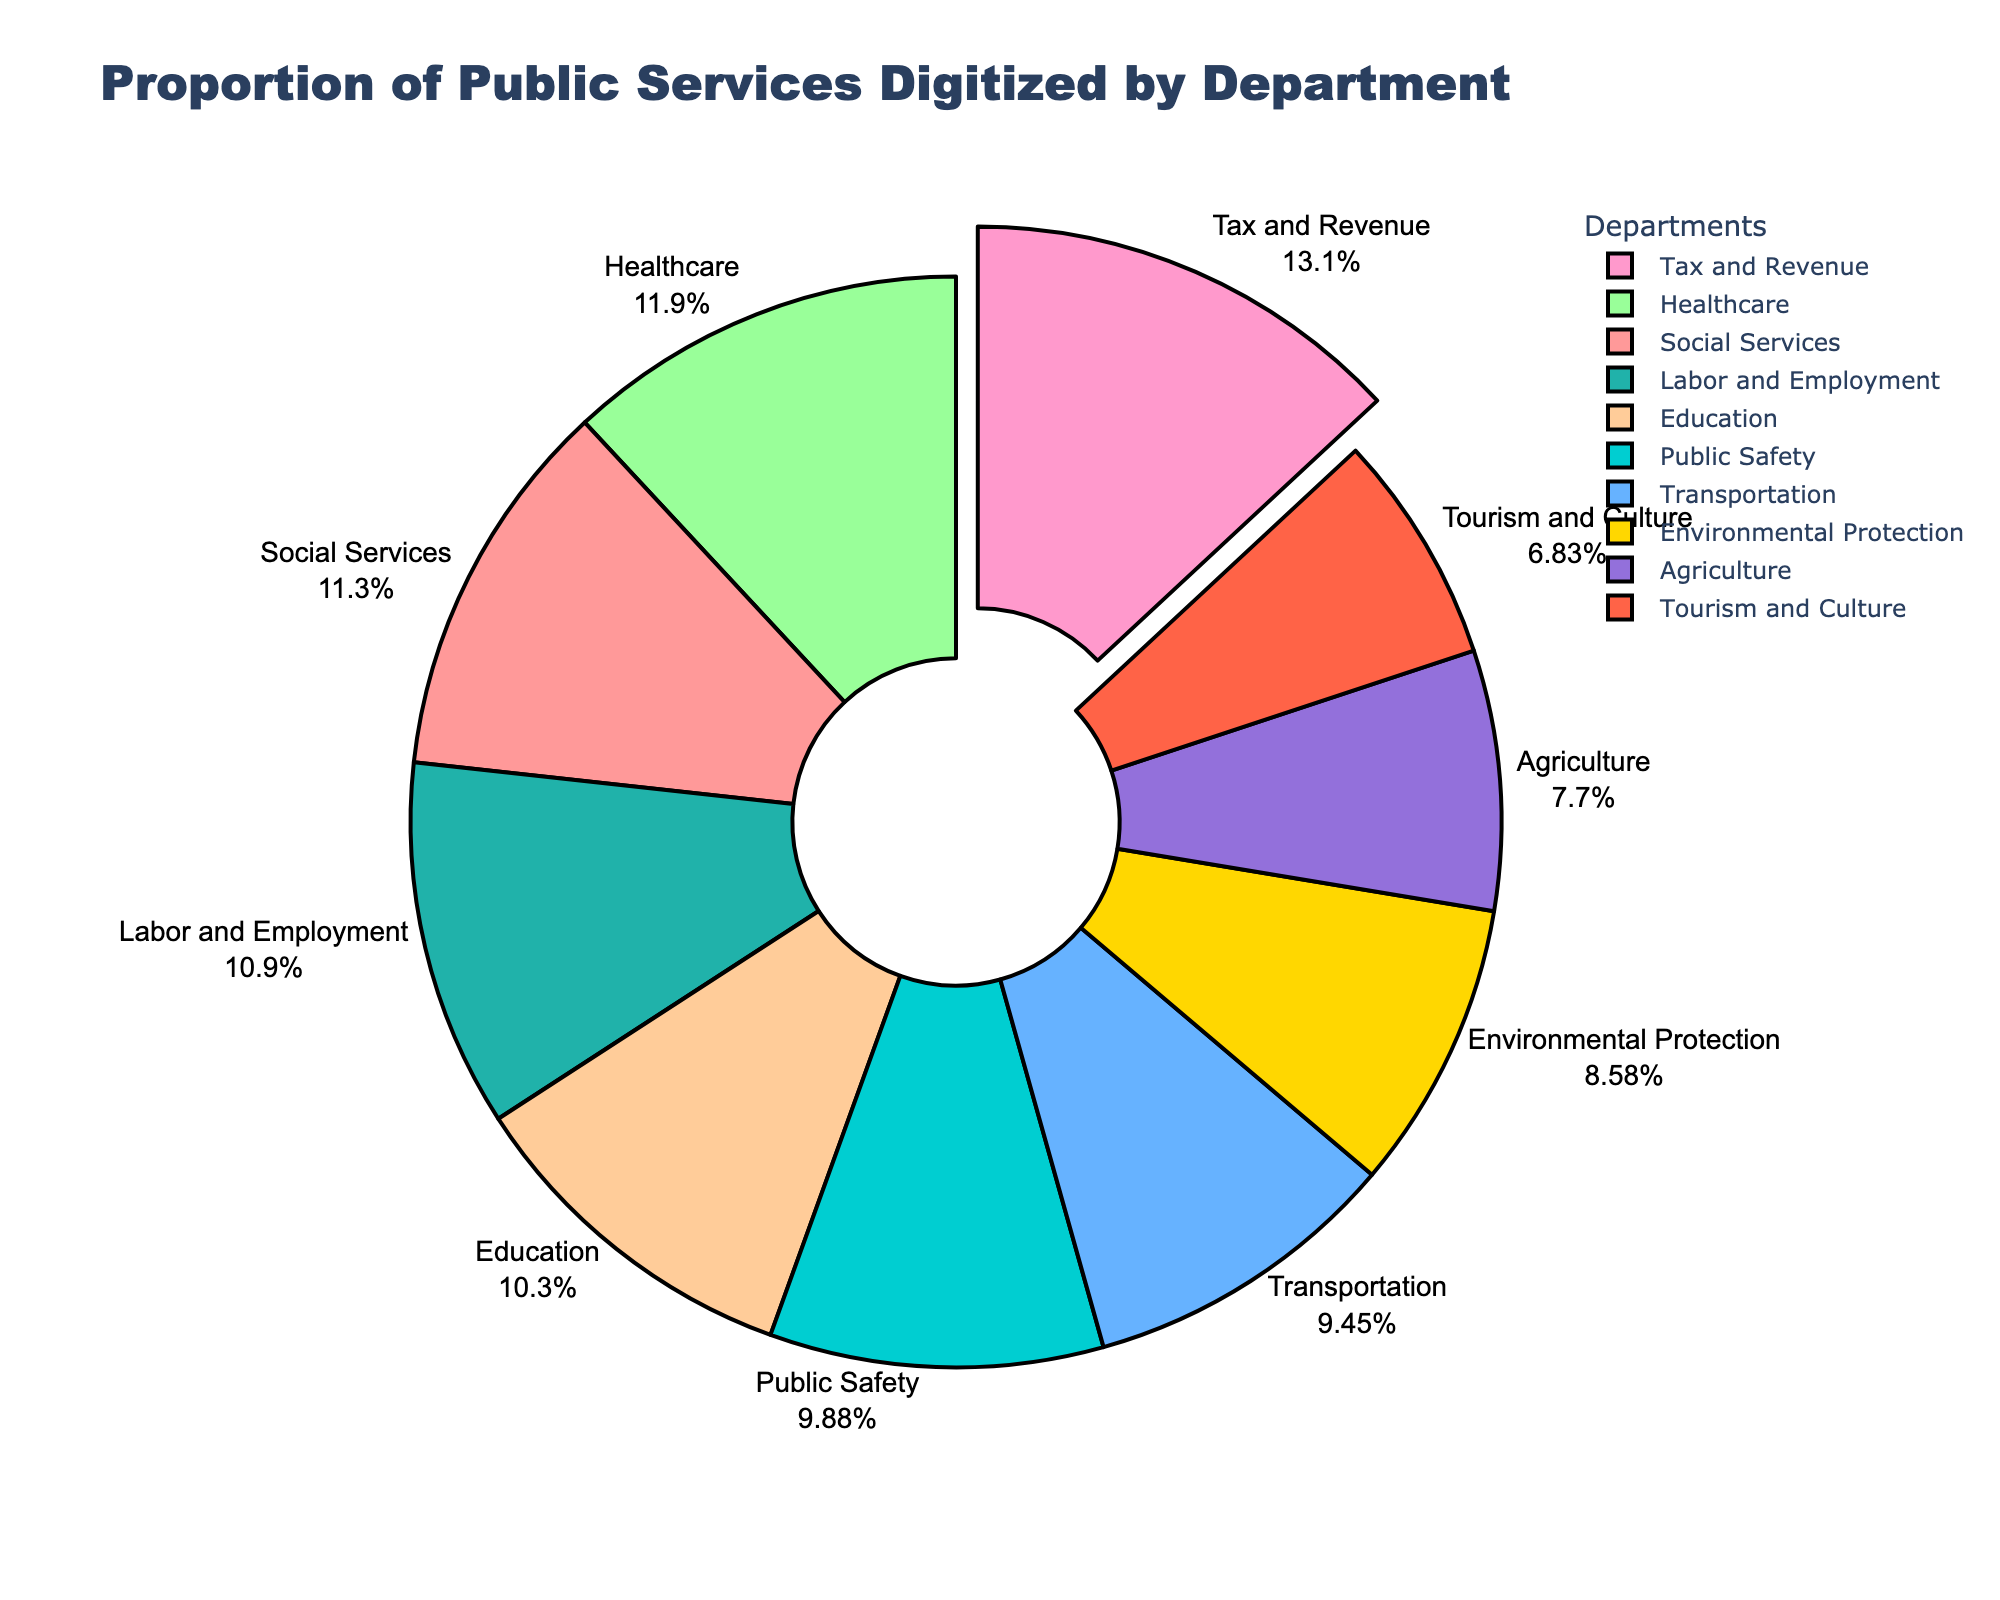What's the department with the highest proportion of digitized public services? The slice of the pie chart that is pulled out represents the department with the highest percentage of digitized public services, which is Tax and Revenue.
Answer: Tax and Revenue What's the difference in percentage between the highest and the lowest proportion of digitized services? The highest proportion is Tax and Revenue with 90%, and the lowest is Tourism and Culture with 47%. The difference is found by subtracting 47% from 90%.
Answer: 43% Which department has a higher proportion of digitized services, Healthcare or Transportation? By looking at the pie chart, Healthcare has 82% while Transportation has 65%. Therefore, Healthcare has a higher proportion.
Answer: Healthcare What proportion of digitized services do Environmental Protection and Agriculture account for together? Adding the percentages for Environmental Protection (59%) and Agriculture (53%) gives the combined proportion.
Answer: 112% Among Social Services, Education, and Labor and Employment, which department is in the middle in terms of digitized services proportion? Social Services has 78%, Education has 71%, and Labor and Employment has 75%. The middle value is 75%, corresponding to Labor and Employment.
Answer: Labor and Employment What is the average proportion of digitized services across all departments? Adding all the percentages together and dividing by the number of departments: (78 + 65 + 82 + 71 + 90 + 59 + 68 + 53 + 75 + 47) / 10 = 688 / 10.
Answer: 68.8% Which departments are shown in blue and green? By referring to the pie chart, the colors blue and green are used for Transportation and Healthcare.
Answer: Transportation and Healthcare Is the proportion of digitized services in Education greater than in Public Safety? Comparing the two percentages: Education has 71% and Public Safety has 68%. Hence, Education has a greater proportion.
Answer: Yes How much less digitized is Tourism and Culture compared to Social Services? Subtract the percentage for Tourism and Culture (47%) from that of Social Services (78%) to find the difference.
Answer: 31% Are there more departments with proportions over 70% or under 70%? By counting and comparing: over 70% - (Social Services, Healthcare, Tax and Revenue, Education, Labor and Employment) 5 departments, under 70% - (Transportation, Environmental Protection, Public Safety, Agriculture, Tourism and Culture) 5 departments. The numbers are the same.
Answer: Equal 